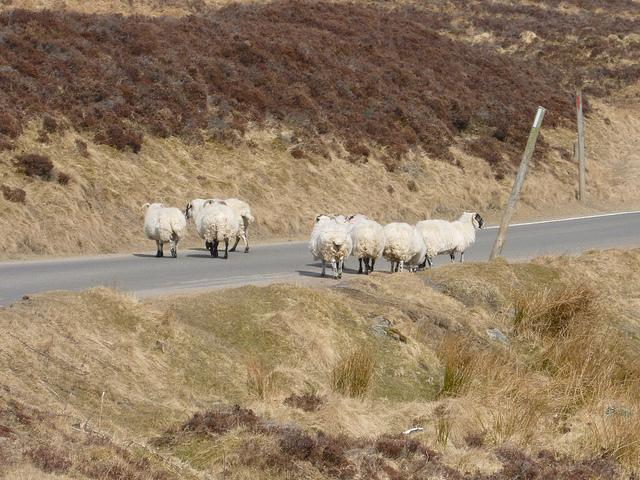What is the fur of the animal in this image commonly used for? wool 